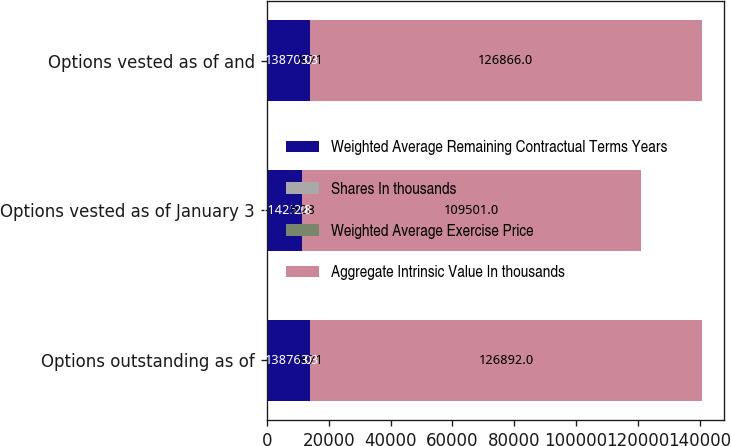<chart> <loc_0><loc_0><loc_500><loc_500><stacked_bar_chart><ecel><fcel>Options outstanding as of<fcel>Options vested as of January 3<fcel>Options vested as of and<nl><fcel>Weighted Average Remaining Contractual Terms Years<fcel>13876<fcel>11425<fcel>13870<nl><fcel>Shares In thousands<fcel>9.71<fcel>9.28<fcel>9.71<nl><fcel>Weighted Average Exercise Price<fcel>3.3<fcel>2.8<fcel>3.3<nl><fcel>Aggregate Intrinsic Value In thousands<fcel>126892<fcel>109501<fcel>126866<nl></chart> 